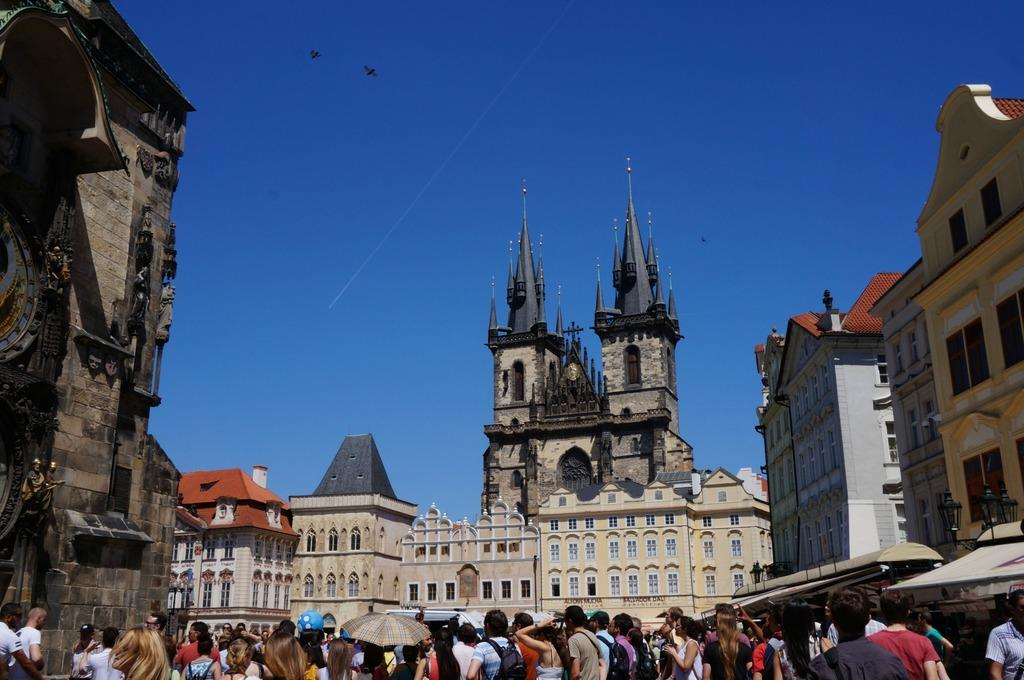What is located in the foreground of the image? There are people in the foreground of the image. What can be seen on the sides of the image? There are buildings on either side of the image. What is visible in the background of the image? There are buildings and the sky in the background of the image. What is happening in the sky in the background of the image? There are birds flying in the air in the background of the image. What type of toothpaste is being used by the people in the image? There is no toothpaste present in the image; it features people, buildings, and birds in the sky. Can you see any stars in the image? There are no stars visible in the image; it features people, buildings, and birds in the sky. 